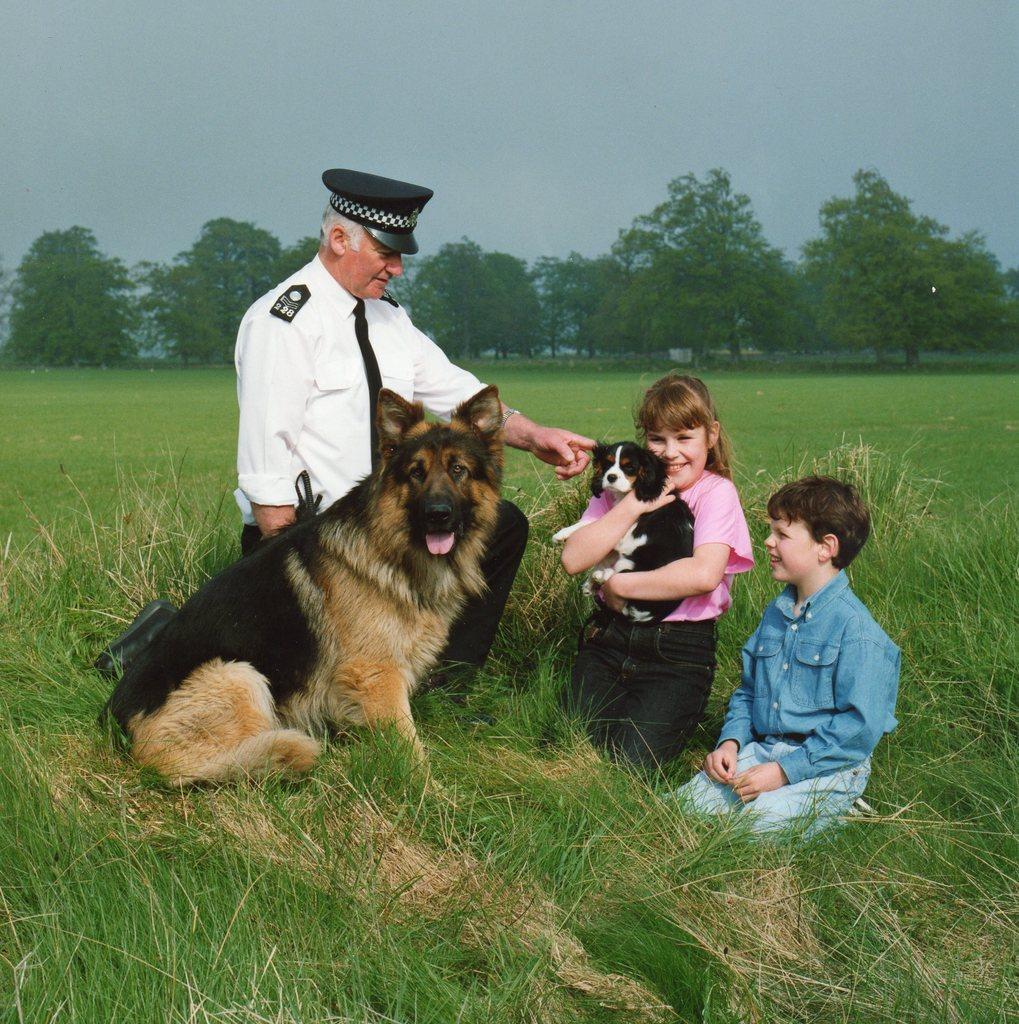Can you describe this image briefly? This is a picture in the field where we have some trees and grass and there are three people and two dogs sitting on the grass. 